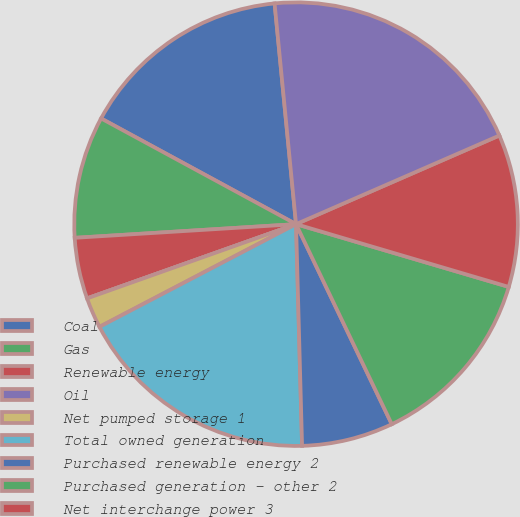<chart> <loc_0><loc_0><loc_500><loc_500><pie_chart><fcel>Coal<fcel>Gas<fcel>Renewable energy<fcel>Oil<fcel>Net pumped storage 1<fcel>Total owned generation<fcel>Purchased renewable energy 2<fcel>Purchased generation - other 2<fcel>Net interchange power 3<fcel>Total purchased and<nl><fcel>15.55%<fcel>8.89%<fcel>4.45%<fcel>0.0%<fcel>2.23%<fcel>17.77%<fcel>6.67%<fcel>13.33%<fcel>11.11%<fcel>20.0%<nl></chart> 